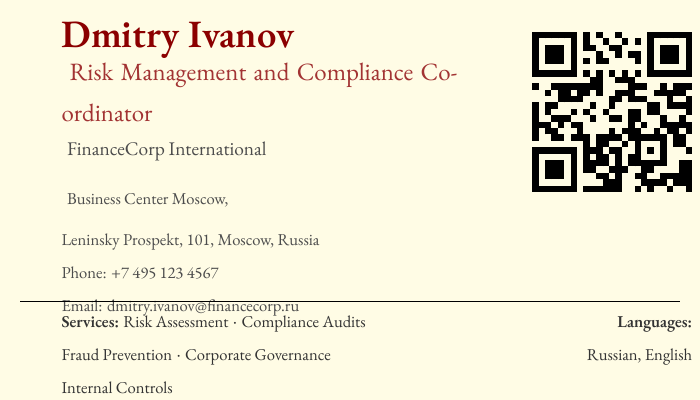what is the name of the coordinator? The name of the coordinator is prominently displayed in the document.
Answer: Dmitry Ivanov what is the title mentioned on the business card? The title is listed right below the name.
Answer: Risk Management and Compliance Coordinator which company does Dmitry Ivanov work for? The company name is clearly stated in the document.
Answer: FinanceCorp International where is the office located? The address details are provided on the card.
Answer: Business Center Moscow, Leninsky Prospekt, 101, Moscow, Russia what phone number is provided? The contact phone number is indicated on the business card.
Answer: +7 495 123 4567 what are the services mentioned on the card? The card lists several services that Dmitry is involved with.
Answer: Risk Assessment · Compliance Audits · Fraud Prevention · Corporate Governance · Internal Controls which languages can Dmitry speak? The languages spoken are specified in a section of the card.
Answer: Russian, English what is the quote mentioned on the card? There is a motivational quote provided at the bottom of the business card.
Answer: "Mitigating risks, ensuring compliance for corporate excellence." what is the height of the QR code? The height of the QR code is explicitly given in the document.
Answer: 0.8 inches 